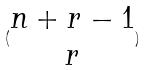Convert formula to latex. <formula><loc_0><loc_0><loc_500><loc_500>( \begin{matrix} n + r - 1 \\ r \end{matrix} )</formula> 